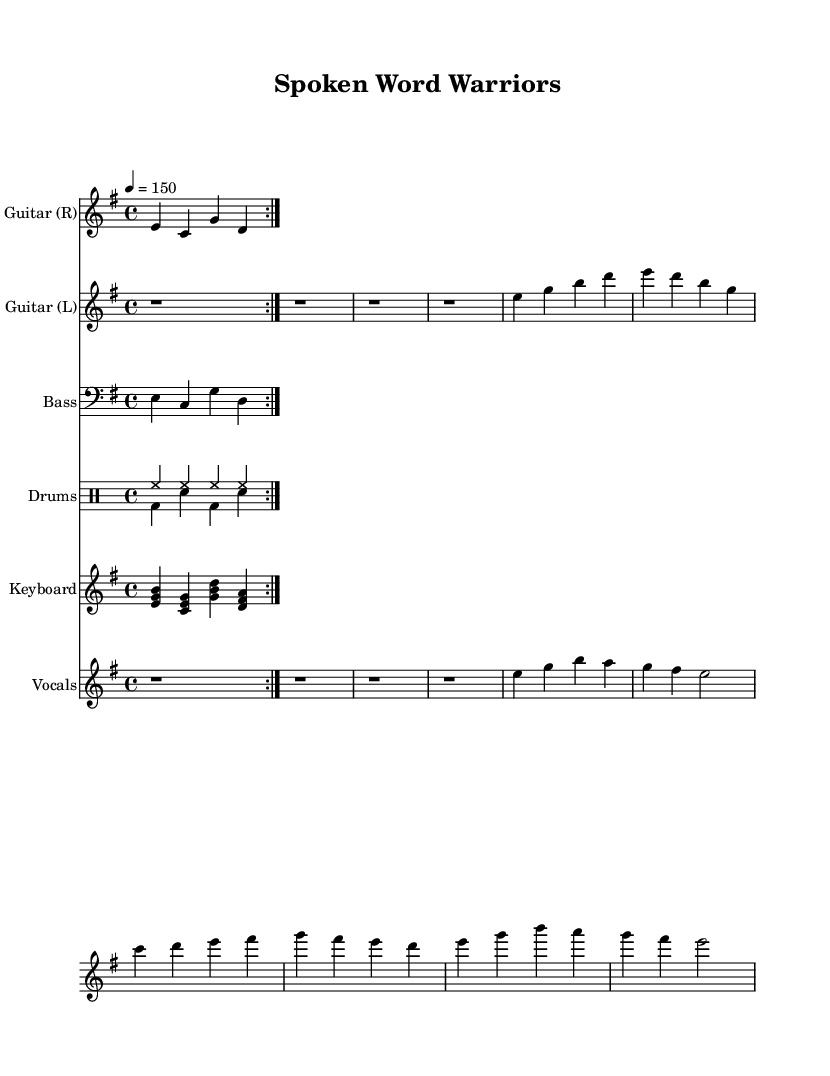What is the key signature of this music? The key signature is indicated by the key at the beginning of the staff system. In this case, it shows an E minor key signature, which has one sharp (F#).
Answer: E minor What is the time signature of this music? The time signature is shown at the beginning of the staff system, which indicates how many beats are in each measure. Here, it is 4/4, meaning there are four beats per measure.
Answer: 4/4 What is the tempo of this music? The tempo is specified at the beginning of the score, showing the speed of the music. It reads "4 = 150," which means there should be 150 beats per minute.
Answer: 150 How many measures are in the electric guitar rhythm part? The electric guitar rhythm part is written with repetition indicated by "volta," which specifies the number of times the section should be played. There are two iterations of the four-measure phrase, totaling eight measures.
Answer: 8 measures What vocal techniques appear in the lyrics? The lyrics feature expressive phrasing that conveys emotion relevant to the theme of audiobooks and literacy. This technique aligns with common vocal styles in power metal aimed at creating an anthem-like feel, particularly in the chorus.
Answer: Expressive phrasing What type of drums are used in this score? The sheet specifies two types of drum patterns: a hi-hat (hh) and bass drum (bd) with snare hits (sn). This dual-drumming approach is characteristic of metal music, providing a driving rhythm.
Answer: Hi-hat and bass drum What is the thematic focus of the lyrics in the song? The lyrics suggest a theme centered around the impact of audiobooks on literacy, emphasizing how words and stories come alive through listening, which promotes engagement and learning. This thematic choice resonates with the metal genre's tradition of storytelling.
Answer: Impact of audiobooks on literacy 